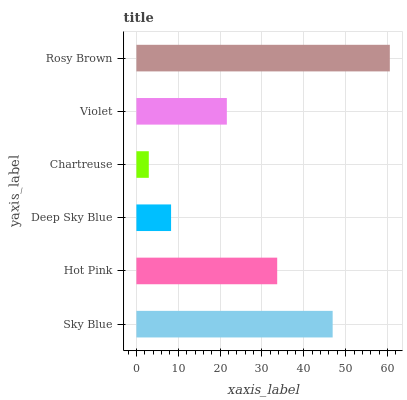Is Chartreuse the minimum?
Answer yes or no. Yes. Is Rosy Brown the maximum?
Answer yes or no. Yes. Is Hot Pink the minimum?
Answer yes or no. No. Is Hot Pink the maximum?
Answer yes or no. No. Is Sky Blue greater than Hot Pink?
Answer yes or no. Yes. Is Hot Pink less than Sky Blue?
Answer yes or no. Yes. Is Hot Pink greater than Sky Blue?
Answer yes or no. No. Is Sky Blue less than Hot Pink?
Answer yes or no. No. Is Hot Pink the high median?
Answer yes or no. Yes. Is Violet the low median?
Answer yes or no. Yes. Is Sky Blue the high median?
Answer yes or no. No. Is Chartreuse the low median?
Answer yes or no. No. 